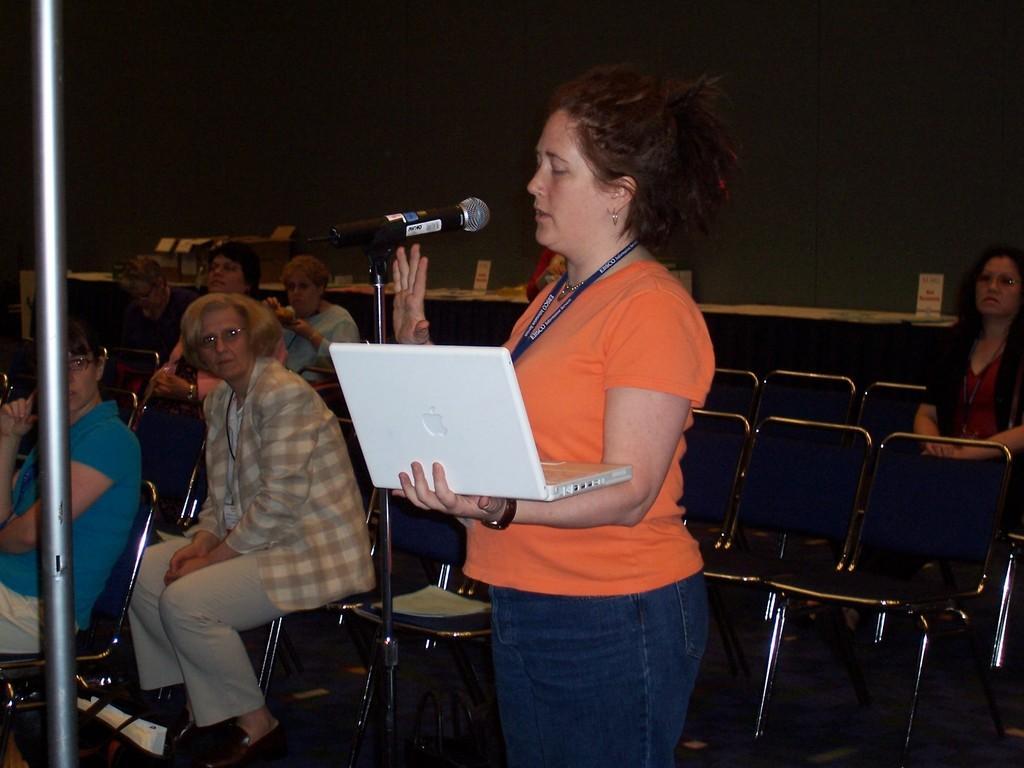How would you summarize this image in a sentence or two? In this picture we can see a group of people where some are sitting on chairs and a woman standing and holding a laptop with her hand and talking on mic and in the background we can see boxes. 